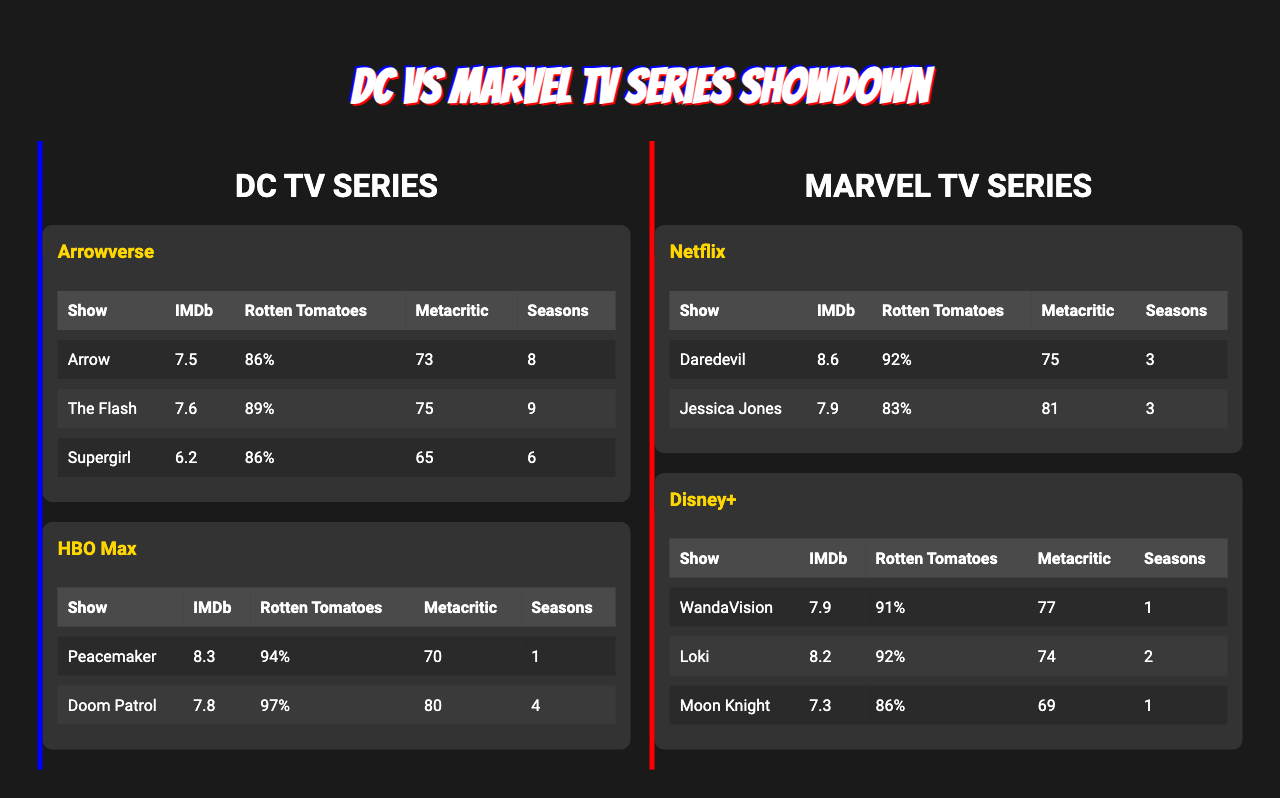What is the IMDb rating of "Doom Patrol"? The table lists the IMDb rating for "Doom Patrol" as 7.8.
Answer: 7.8 Which DC show has the highest Rotten Tomatoes score? "Doom Patrol" has the highest Rotten Tomatoes score at 97%, as shown in the table.
Answer: Doom Patrol What is the average number of seasons for the Marvel TV series listed? The Marvel series have 3 (Daredevil) + 3 (Jessica Jones) + 1 (WandaVision) + 2 (Loki) + 1 (Moon Knight) = 10 total seasons, and there are 5 shows, so the average is 10/5 = 2.
Answer: 2 Is the IMDb rating for "The Flash" higher than that of "Supergirl"? "The Flash" has an IMDb rating of 7.6, while "Supergirl" has 6.2, confirming that "The Flash" is higher.
Answer: Yes What is the Metacritic score difference between "WandaVision" and "Supergirl"? "WandaVision" has a Metacritic score of 77 and "Supergirl" has 65, thus the difference is 77 - 65 = 12.
Answer: 12 Which platform has the highest-rated show based on IMDb ratings? "Daredevil" from Netflix has the highest IMDb rating at 8.6 among all the listed series.
Answer: Daredevil What is the total number of seasons for all DC TV series combined? The total seasons for DC TV series are 8 (Arrow) + 9 (The Flash) + 6 (Supergirl) + 1 (Peacemaker) + 4 (Doom Patrol) = 28 total seasons.
Answer: 28 Does "Peacemaker" have a higher Rotten Tomatoes score than "Jessica Jones"? "Peacemaker" has a Rotten Tomatoes score of 94%, while "Jessica Jones" has 83%, so "Peacemaker" has a higher score.
Answer: Yes Which series has the lowest Metacritic score on the table? "Moon Knight" has the lowest Metacritic score of 69, according to the information provided in the table.
Answer: Moon Knight If you take the average IMDb rating of all DC shows, what would it be? The IMDb ratings for DC shows are 7.5 (Arrow) + 7.6 (The Flash) + 6.2 (Supergirl) + 8.3 (Peacemaker) + 7.8 (Doom Patrol) = 37.4, and there are 5 shows, so 37.4/5 = 7.48.
Answer: 7.48 